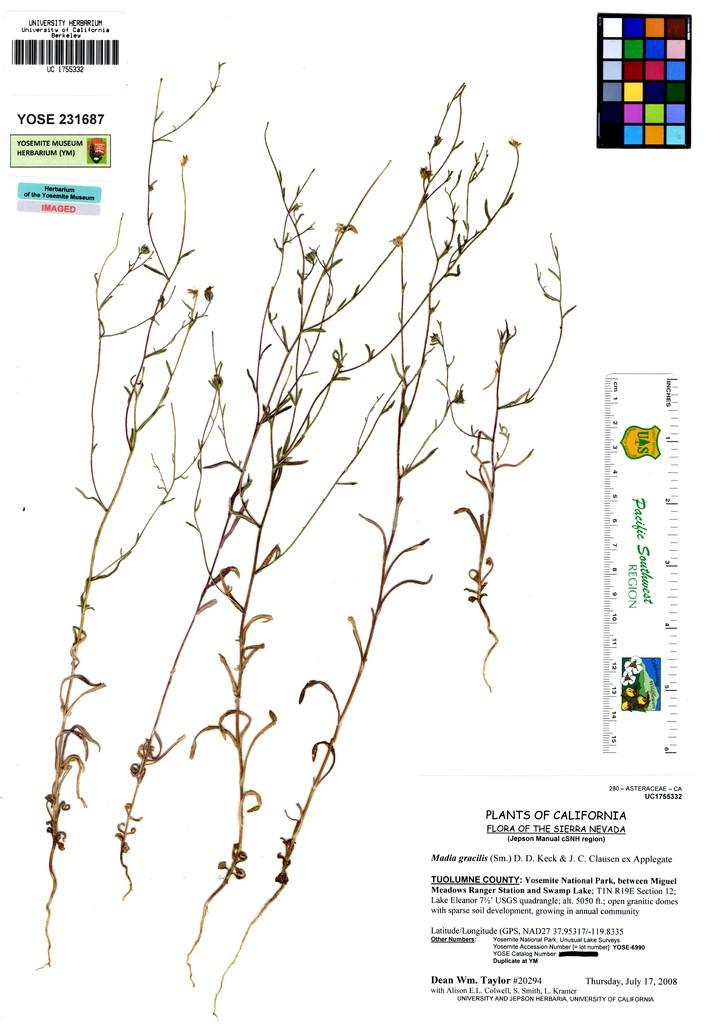What type of living organisms can be seen in the image? Plants can be seen in the image. What is the color of the plants in the image? The plants are brown in color. What is the background color of the image? The background of the image is white. What can be found written in the image? There are words written in the image. What is used for measuring weight in the image? A scale is present in the image. What is used for tracking product information in the image? A barcode is visible in the image. What other items can be seen in the image besides the plants and scale? There are other items in the image. How many girls are playing with dinosaurs in the image? There are no girls or dinosaurs present in the image. What type of list is being used to organize the items in the image? There is no list present in the image. 